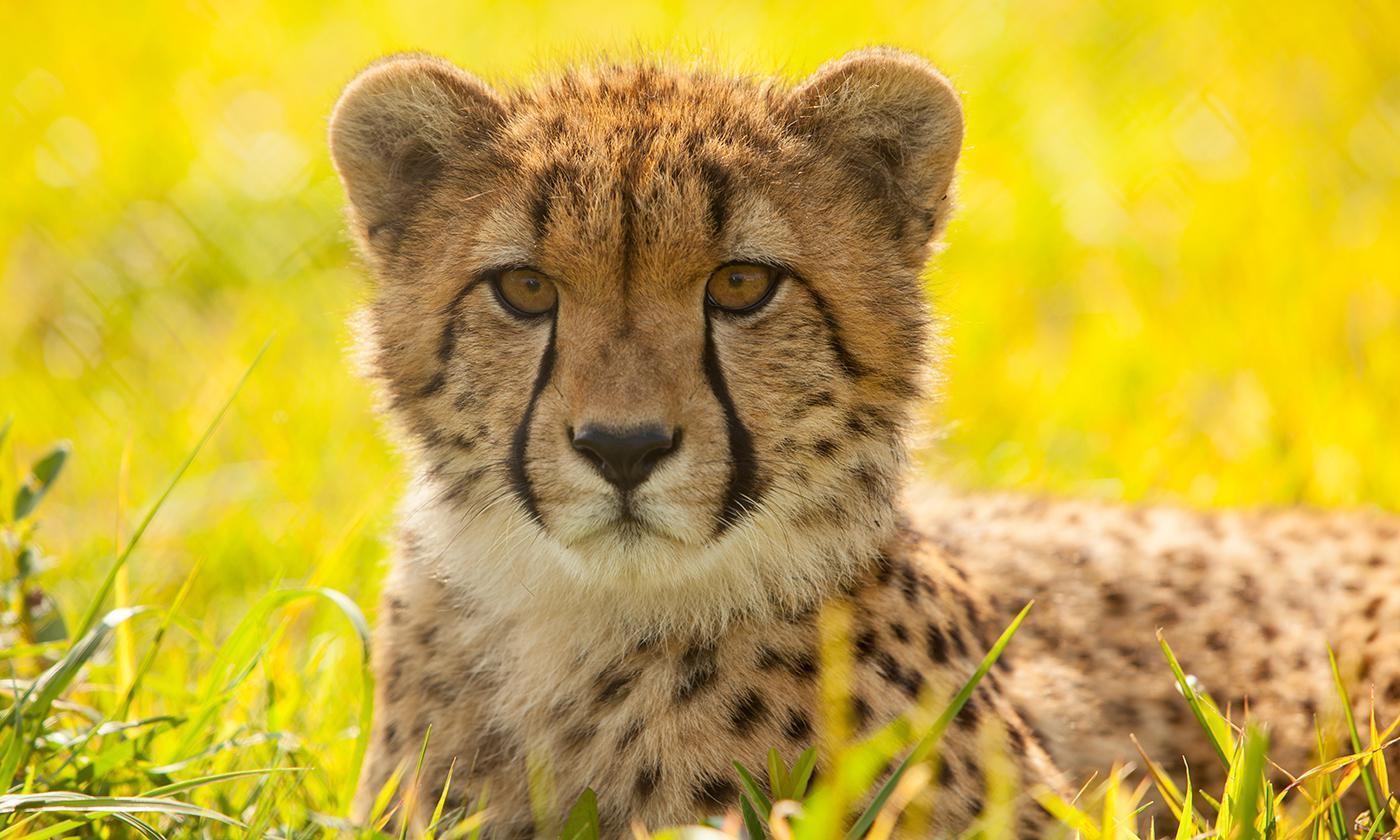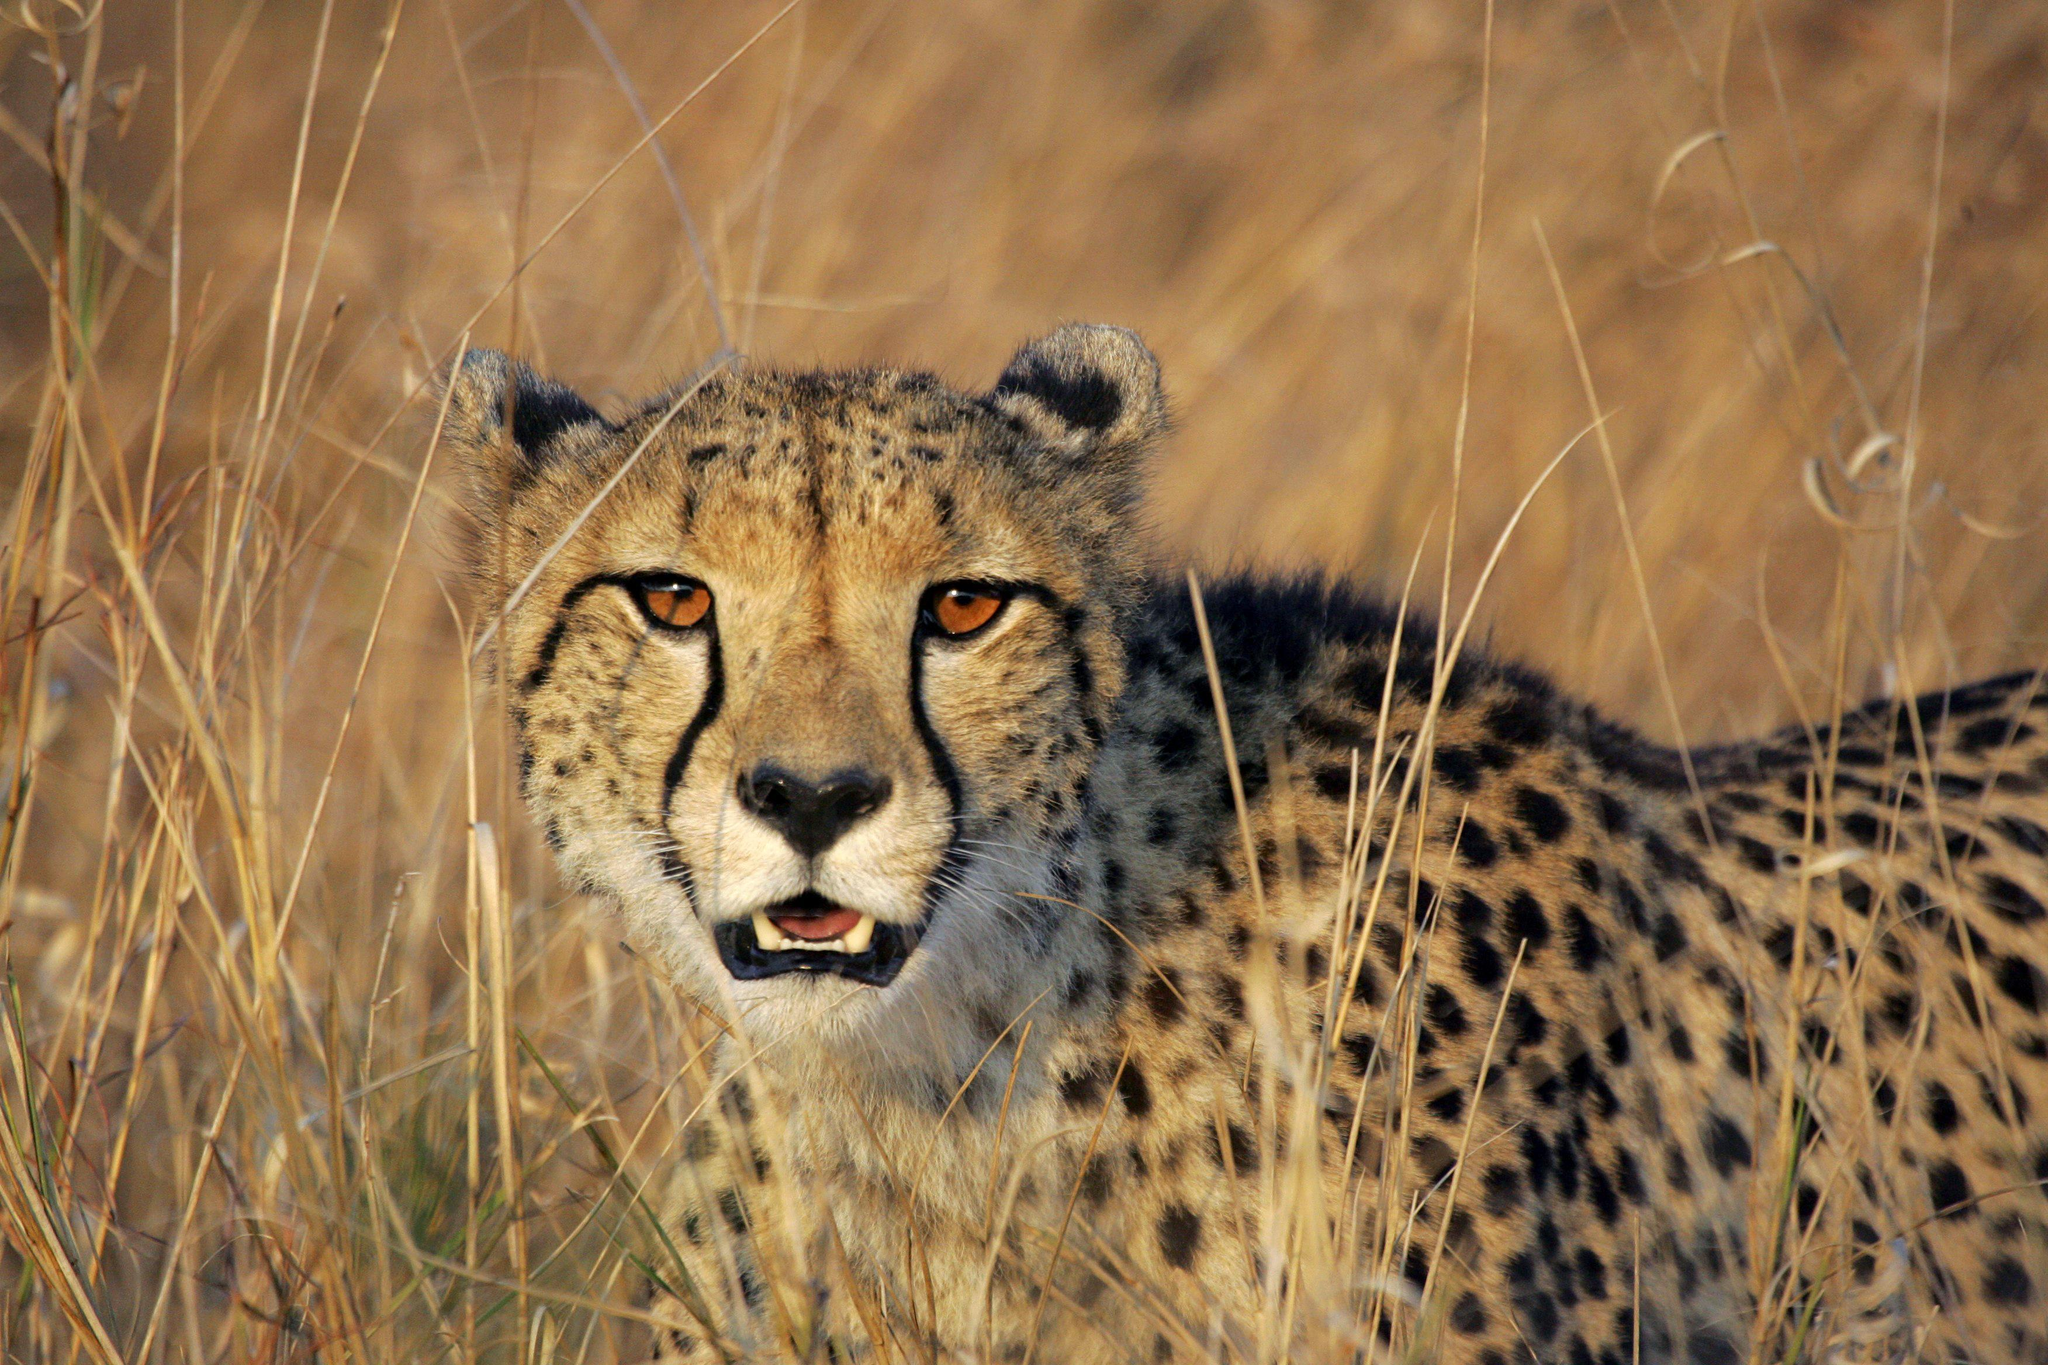The first image is the image on the left, the second image is the image on the right. Considering the images on both sides, is "A cheetah is in bounding pose, with its back legs forward, in front of its front legs." valid? Answer yes or no. No. The first image is the image on the left, the second image is the image on the right. Examine the images to the left and right. Is the description "A single leopard is lying down in the image on the left." accurate? Answer yes or no. Yes. 